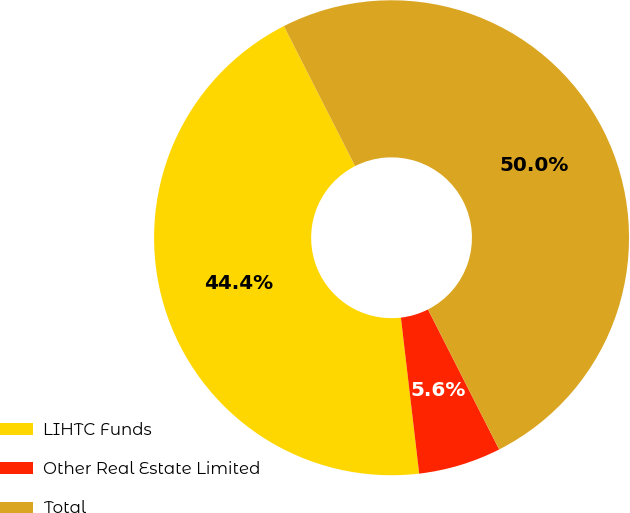Convert chart to OTSL. <chart><loc_0><loc_0><loc_500><loc_500><pie_chart><fcel>LIHTC Funds<fcel>Other Real Estate Limited<fcel>Total<nl><fcel>44.37%<fcel>5.63%<fcel>50.0%<nl></chart> 